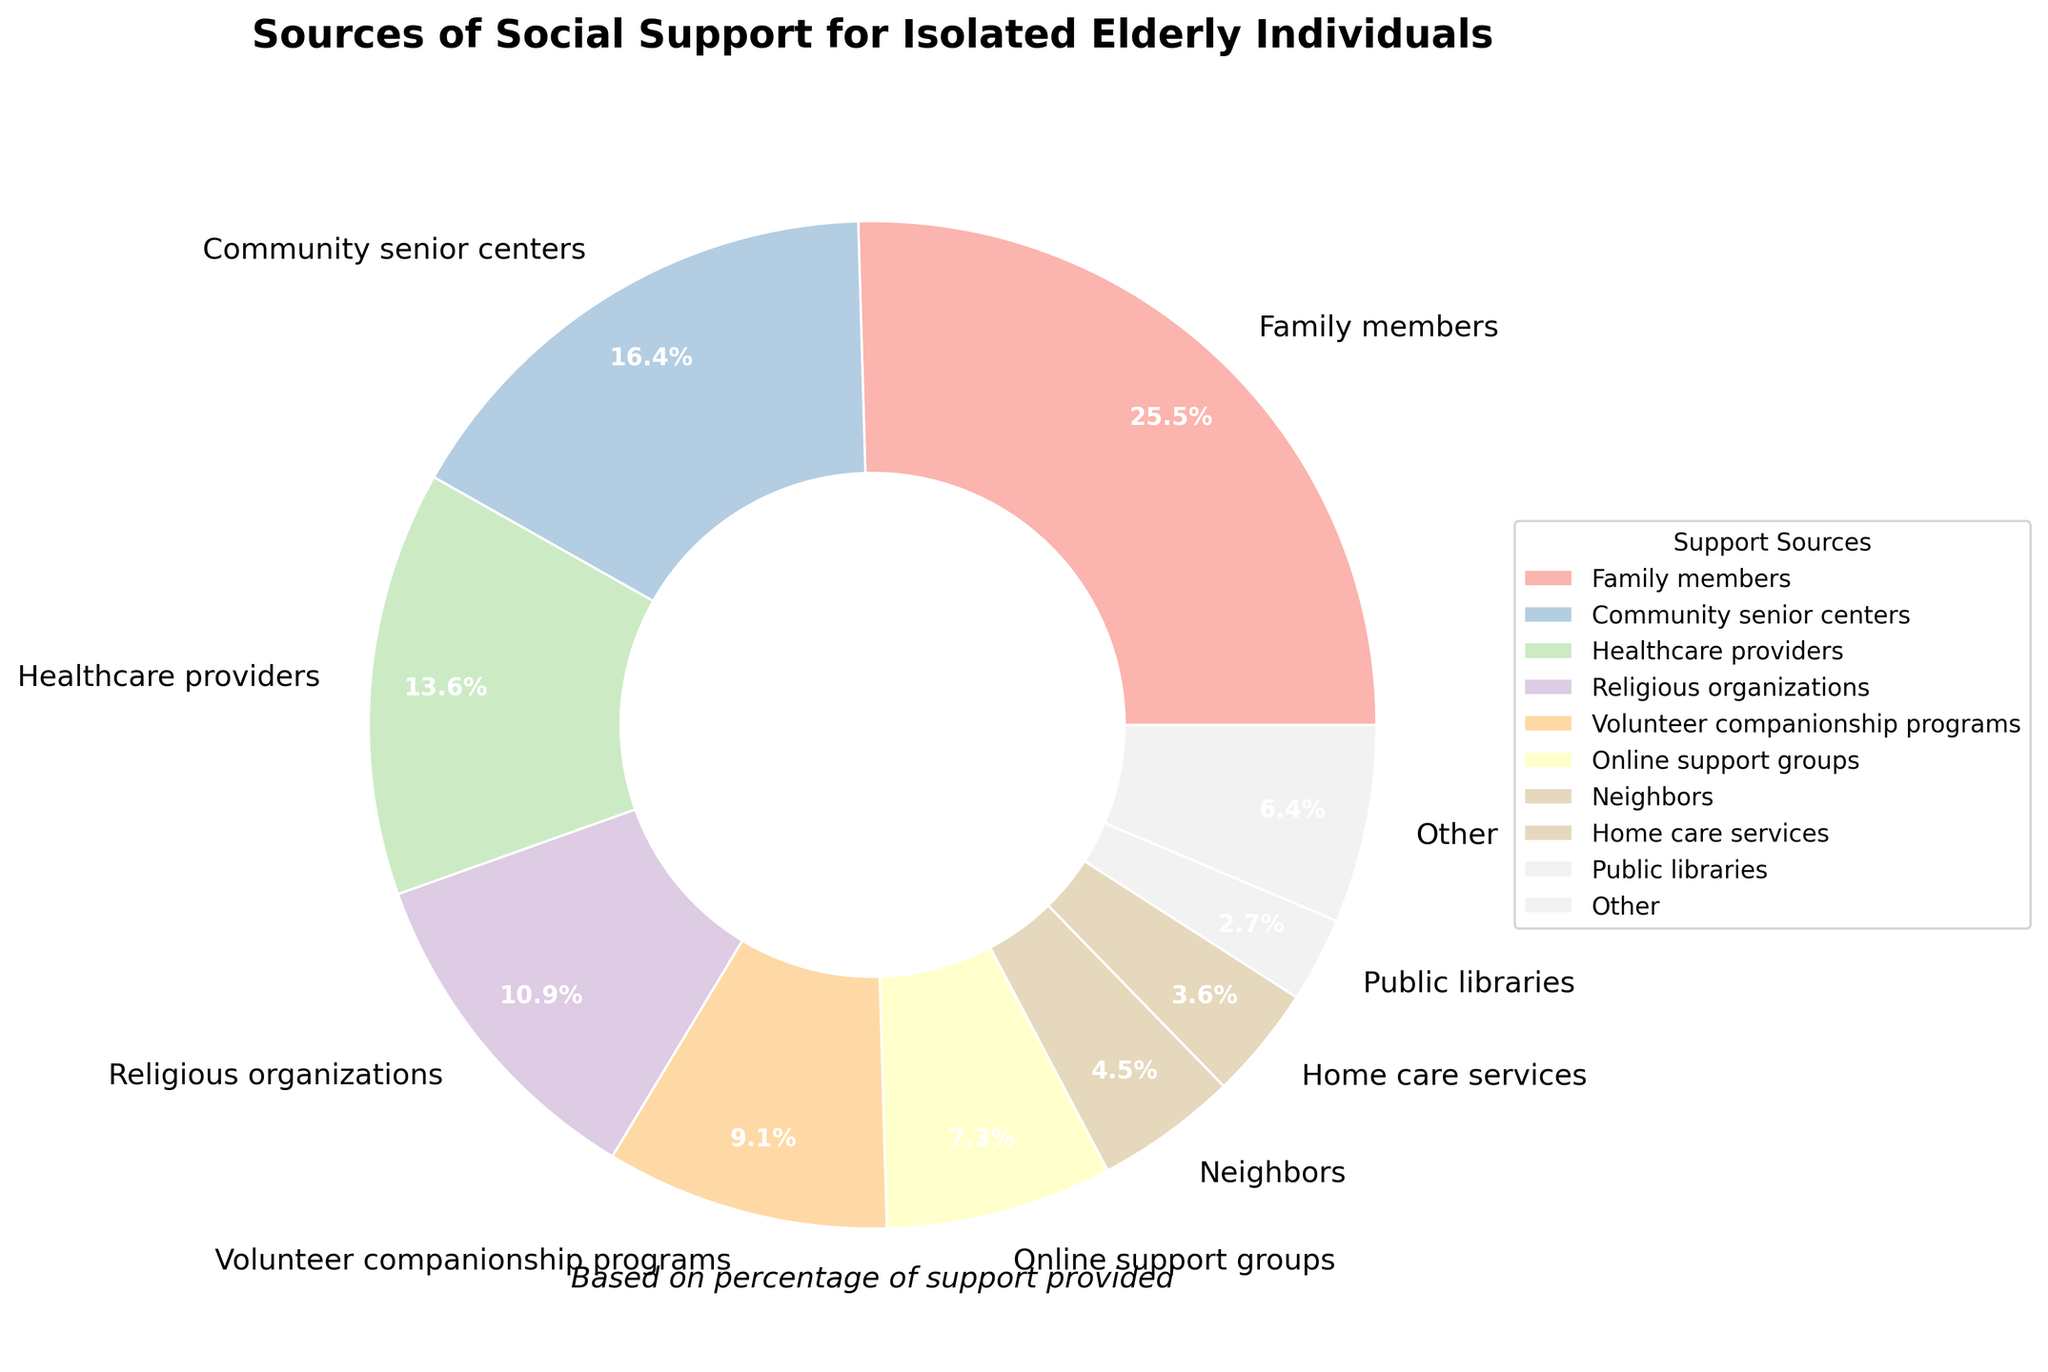Which source provides the largest percentage of social support? According to the pie chart, 'Family members' have the largest segment, which provides 28% of social support.
Answer: Family members What percentage of social support is provided by religious organizations and volunteer companionship programs combined? The percentages for 'Religious organizations' and 'Volunteer companionship programs' are 12% and 10%, respectively. Adding them together gives 12% + 10% = 22%.
Answer: 22% Is the percentage of social support offered by online support groups higher or lower than that provided by healthcare providers? The chart shows that 'Online support groups' provide 8% while 'Healthcare providers' provide 15%. Therefore, online support groups provide a lower percentage.
Answer: Lower What is the difference in percentage between community senior centers and public libraries as sources of social support? 'Community senior centers' provide 18% of social support, whereas 'Public libraries' provide 3%. The difference is 18% - 3% = 15%.
Answer: 15% Do neighbors and home care services combined offer more or less support than community senior centers? 'Neighbors' provide 5% and 'Home care services' provide 4%, summing up to 5% + 4% = 9%. This is less than the 18% provided by 'Community senior centers'.
Answer: Less What visual attribute signifies the category with the least percentage of support in the pie chart? The smallest wedge in the pie chart represents the category with the least percentage of support, which is 'Telephone befriending services' with 1%.
Answer: Smallest wedge Among the listed sources, which ones constitute the "Other" category when percentages below 3% are grouped together? Each category below the 3% threshold is grouped as 'Other'. These categories are 'Pet therapy programs', 'Intergenerational mentoring initiatives', 'Telephone befriending services', and 'Local government outreach', which have percentages of 2%, 2%, 1%, and 2%, respectively. Summing these up gives 7% categorized as 'Other'.
Answer: Pet therapy programs, Intergenerational mentoring initiatives, Telephone befriending services, Local government outreach Does the percentage from family members exceed the combined percentage from community senior centers and healthcare providers? 'Family members' provide 28%. The combined percentage from 'Community senior centers' and 'Healthcare providers' is 18% + 15% = 33%. 28% is less than 33%.
Answer: No What is the combined percentage of social support provided by healthcare providers, religious organizations, and public libraries? The percentages are 15% (Healthcare providers), 12% (Religious organizations), and 3% (Public libraries). Summing them gives 15% + 12% + 3% = 30%.
Answer: 30% Which source is more significant in providing support: volunteer companionship programs or online support groups? 'Volunteer companionship programs' provide 10%, compared to 8% from 'Online support groups'. Thus, volunteer companionship programs are more significant.
Answer: Volunteer companionship programs 